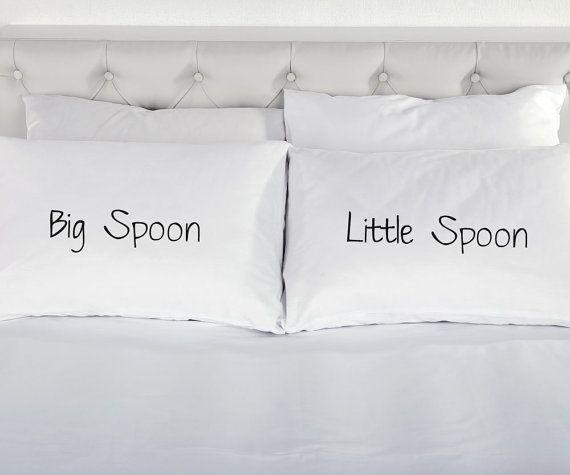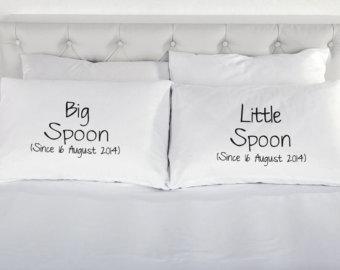The first image is the image on the left, the second image is the image on the right. Assess this claim about the two images: "Each image shows a pair of pillows with text only, side-by-side on a bed with all-white bedding.". Correct or not? Answer yes or no. Yes. The first image is the image on the left, the second image is the image on the right. Evaluate the accuracy of this statement regarding the images: "The writing in the right image is cursive.". Is it true? Answer yes or no. No. 